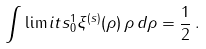Convert formula to latex. <formula><loc_0><loc_0><loc_500><loc_500>\int \lim i t s _ { 0 } ^ { 1 } \xi ^ { ( s ) } ( \rho ) \, \rho \, d \rho = \frac { 1 } { 2 } \, .</formula> 